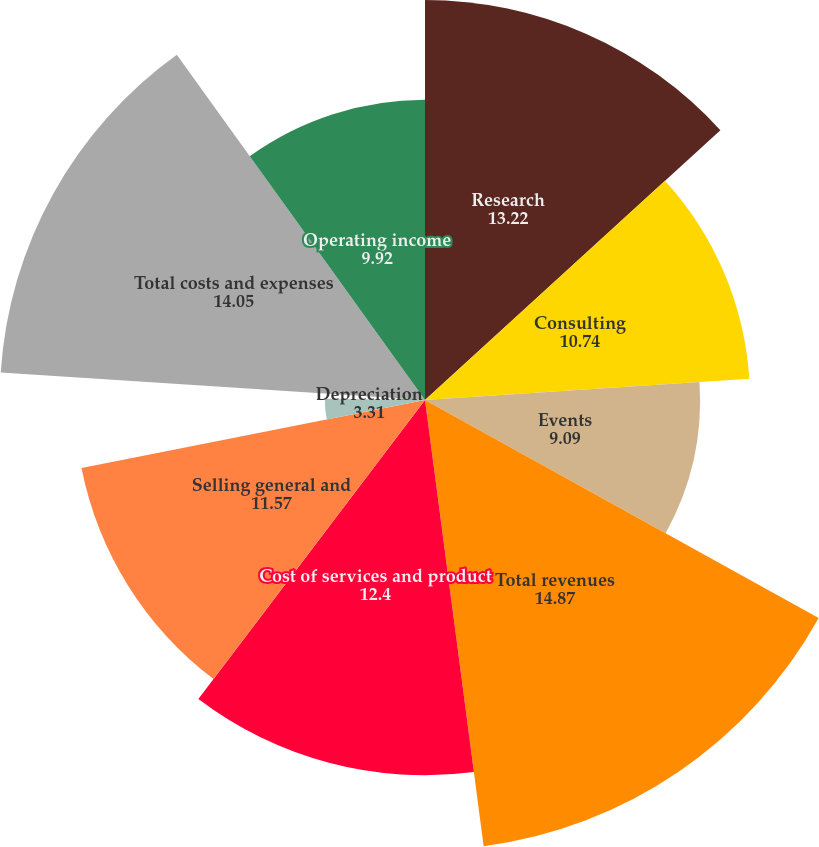Convert chart to OTSL. <chart><loc_0><loc_0><loc_500><loc_500><pie_chart><fcel>Research<fcel>Consulting<fcel>Events<fcel>Total revenues<fcel>Cost of services and product<fcel>Selling general and<fcel>Depreciation<fcel>Amortization of intangibles<fcel>Total costs and expenses<fcel>Operating income<nl><fcel>13.22%<fcel>10.74%<fcel>9.09%<fcel>14.87%<fcel>12.4%<fcel>11.57%<fcel>3.31%<fcel>0.83%<fcel>14.05%<fcel>9.92%<nl></chart> 